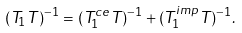<formula> <loc_0><loc_0><loc_500><loc_500>( T _ { 1 } T ) ^ { - 1 } = ( T _ { 1 } ^ { c e } T ) ^ { - 1 } + ( T _ { 1 } ^ { i m p } T ) ^ { - 1 } .</formula> 